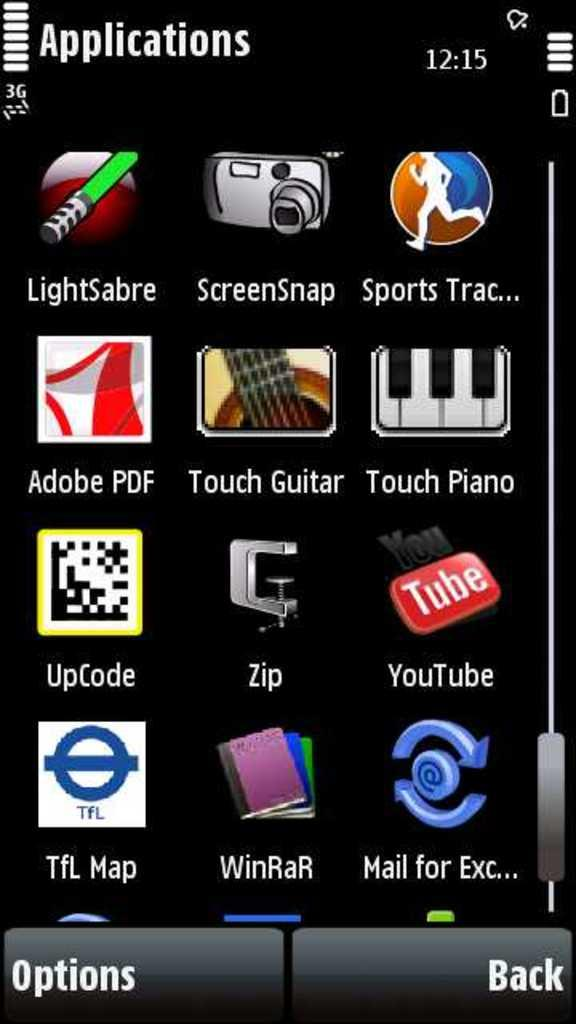Provide a one-sentence caption for the provided image. A screenshot of an app page is shown, the apps include YouTube, UpCode, Adobe PDF, and Touch Piano. 